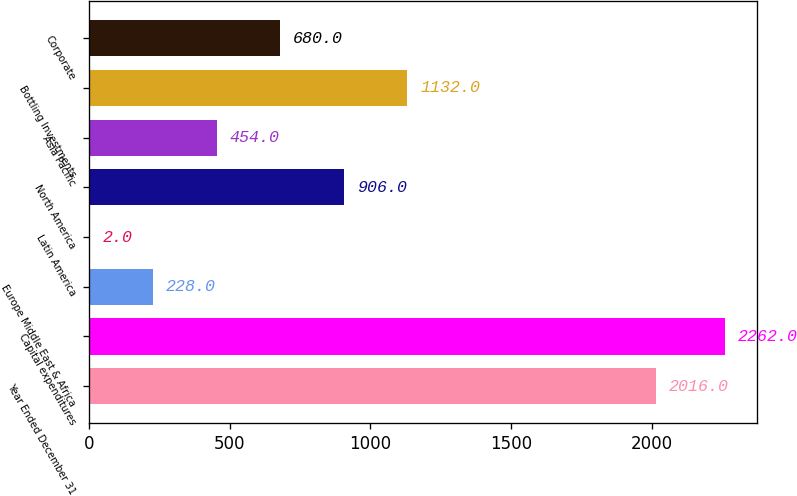<chart> <loc_0><loc_0><loc_500><loc_500><bar_chart><fcel>Year Ended December 31<fcel>Capital expenditures<fcel>Europe Middle East & Africa<fcel>Latin America<fcel>North America<fcel>Asia Pacific<fcel>Bottling Investments<fcel>Corporate<nl><fcel>2016<fcel>2262<fcel>228<fcel>2<fcel>906<fcel>454<fcel>1132<fcel>680<nl></chart> 